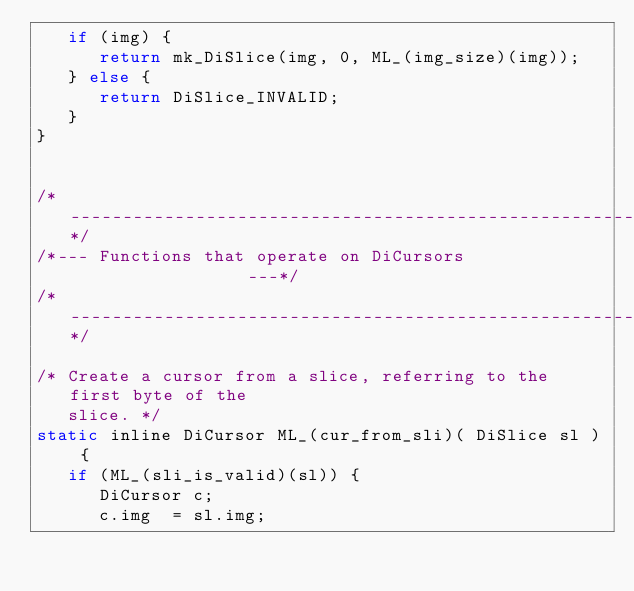Convert code to text. <code><loc_0><loc_0><loc_500><loc_500><_C_>   if (img) {
      return mk_DiSlice(img, 0, ML_(img_size)(img));
   } else {
      return DiSlice_INVALID;
   }
}


/*------------------------------------------------------------*/
/*--- Functions that operate on DiCursors                  ---*/
/*------------------------------------------------------------*/

/* Create a cursor from a slice, referring to the first byte of the
   slice. */
static inline DiCursor ML_(cur_from_sli)( DiSlice sl ) {
   if (ML_(sli_is_valid)(sl)) {
      DiCursor c;
      c.img  = sl.img;</code> 